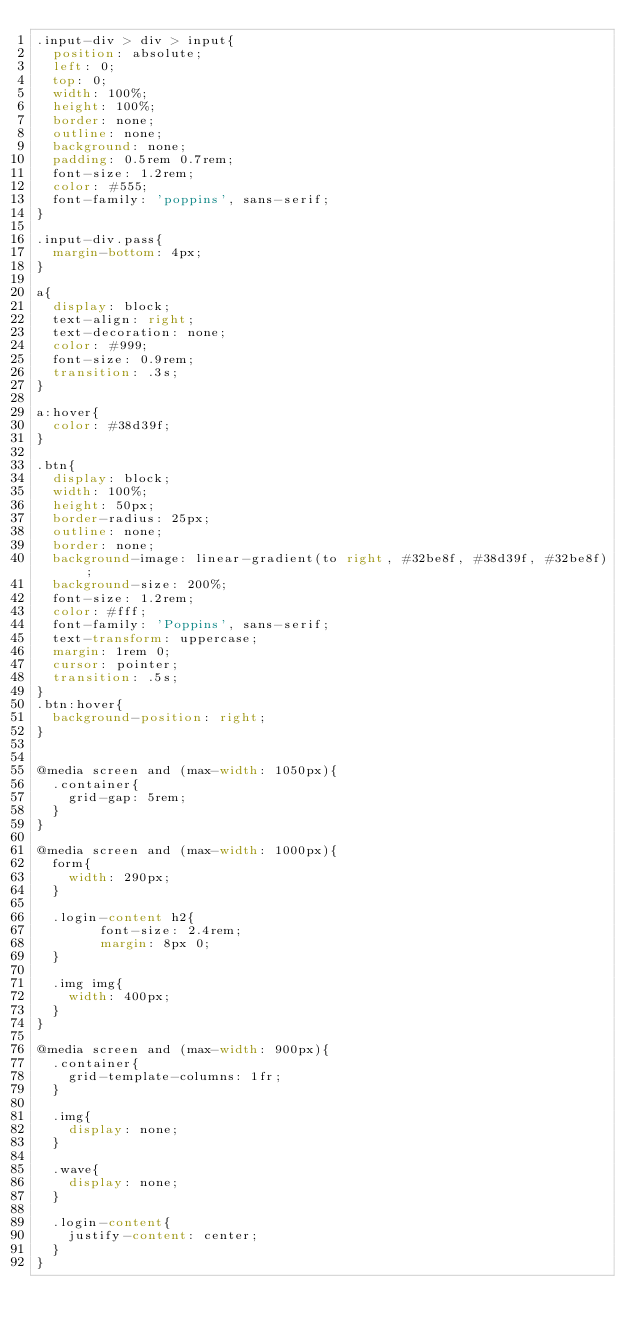Convert code to text. <code><loc_0><loc_0><loc_500><loc_500><_CSS_>.input-div > div > input{
  position: absolute;
  left: 0;
  top: 0;
  width: 100%;
  height: 100%;
  border: none;
  outline: none;
  background: none;
  padding: 0.5rem 0.7rem;
  font-size: 1.2rem;
  color: #555;
  font-family: 'poppins', sans-serif;
}

.input-div.pass{
  margin-bottom: 4px;
}

a{
  display: block;
  text-align: right;
  text-decoration: none;
  color: #999;
  font-size: 0.9rem;
  transition: .3s;
}

a:hover{
  color: #38d39f;
}

.btn{
  display: block;
  width: 100%;
  height: 50px;
  border-radius: 25px;
  outline: none;
  border: none;
  background-image: linear-gradient(to right, #32be8f, #38d39f, #32be8f);
  background-size: 200%;
  font-size: 1.2rem;
  color: #fff;
  font-family: 'Poppins', sans-serif;
  text-transform: uppercase;
  margin: 1rem 0;
  cursor: pointer;
  transition: .5s;
}
.btn:hover{
  background-position: right;
}


@media screen and (max-width: 1050px){
  .container{
    grid-gap: 5rem;
  }
}

@media screen and (max-width: 1000px){
  form{
    width: 290px;
  }

  .login-content h2{
        font-size: 2.4rem;
        margin: 8px 0;
  }

  .img img{
    width: 400px;
  }
}

@media screen and (max-width: 900px){
  .container{
    grid-template-columns: 1fr;
  }

  .img{
    display: none;
  }

  .wave{
    display: none;
  }

  .login-content{
    justify-content: center;
  }
}
</code> 